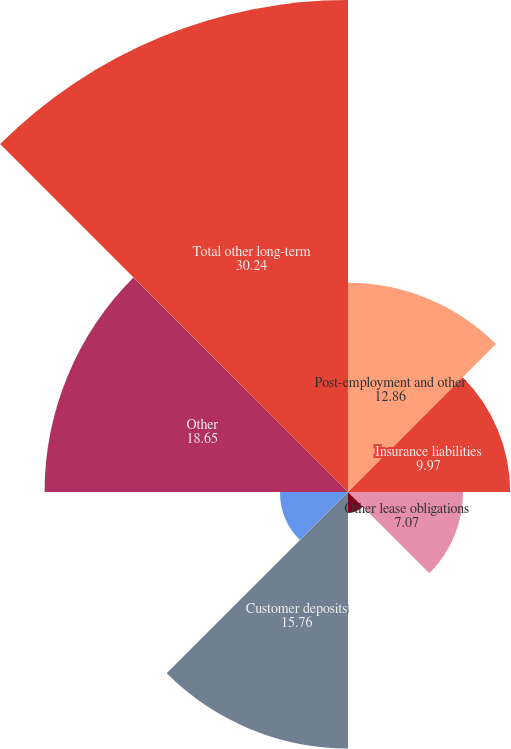Convert chart to OTSL. <chart><loc_0><loc_0><loc_500><loc_500><pie_chart><fcel>Post-employment and other<fcel>Insurance liabilities<fcel>Other lease obligations<fcel>Other taxes payable<fcel>Customer deposits<fcel>Guarantees related to<fcel>Other<fcel>Total other long-term<nl><fcel>12.86%<fcel>9.97%<fcel>7.07%<fcel>1.28%<fcel>15.76%<fcel>4.18%<fcel>18.65%<fcel>30.24%<nl></chart> 